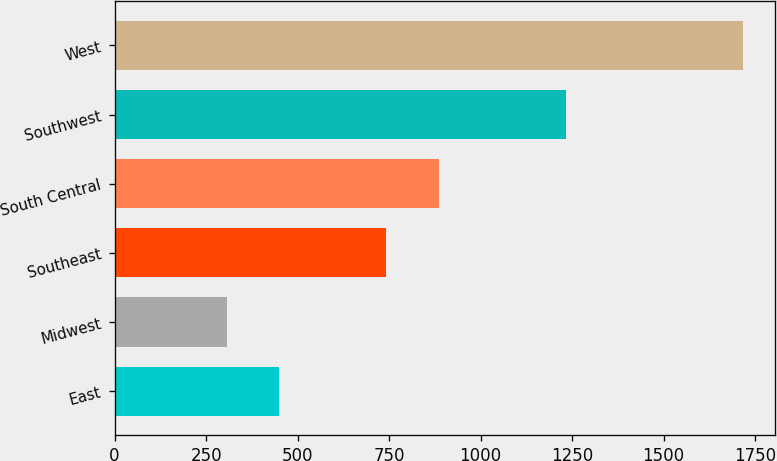Convert chart to OTSL. <chart><loc_0><loc_0><loc_500><loc_500><bar_chart><fcel>East<fcel>Midwest<fcel>Southeast<fcel>South Central<fcel>Southwest<fcel>West<nl><fcel>448.55<fcel>307.5<fcel>742.3<fcel>885.8<fcel>1234.2<fcel>1718<nl></chart> 